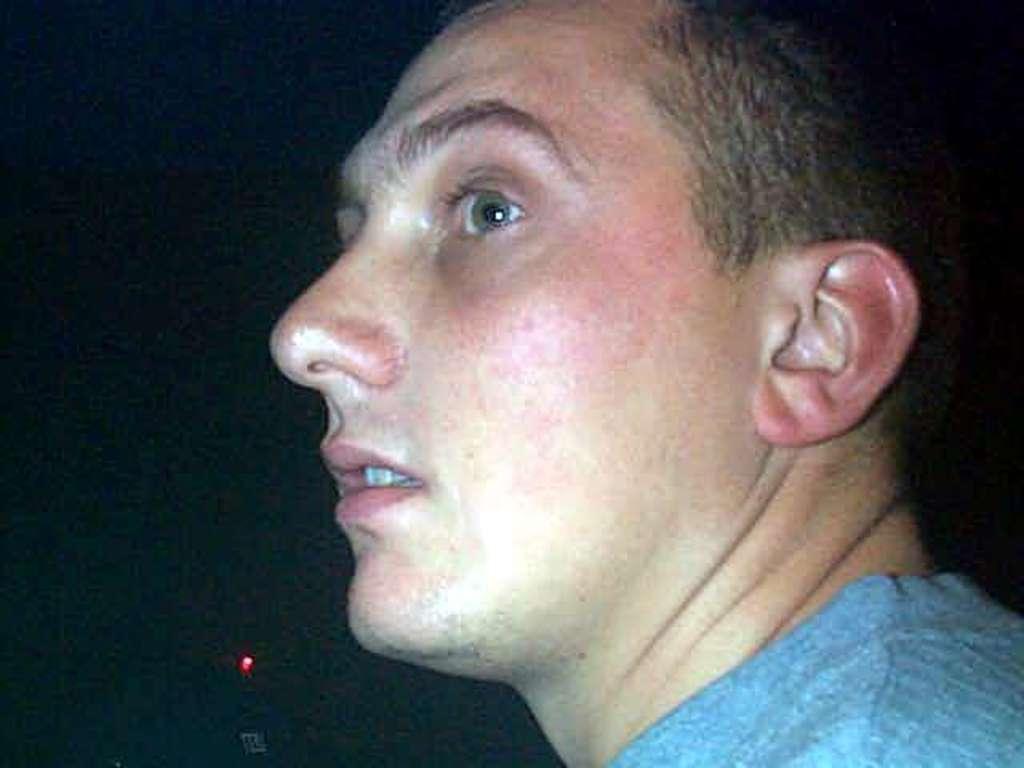Can you describe this image briefly? In this picture we can see a man. Behind the man there is light and the dark background. 